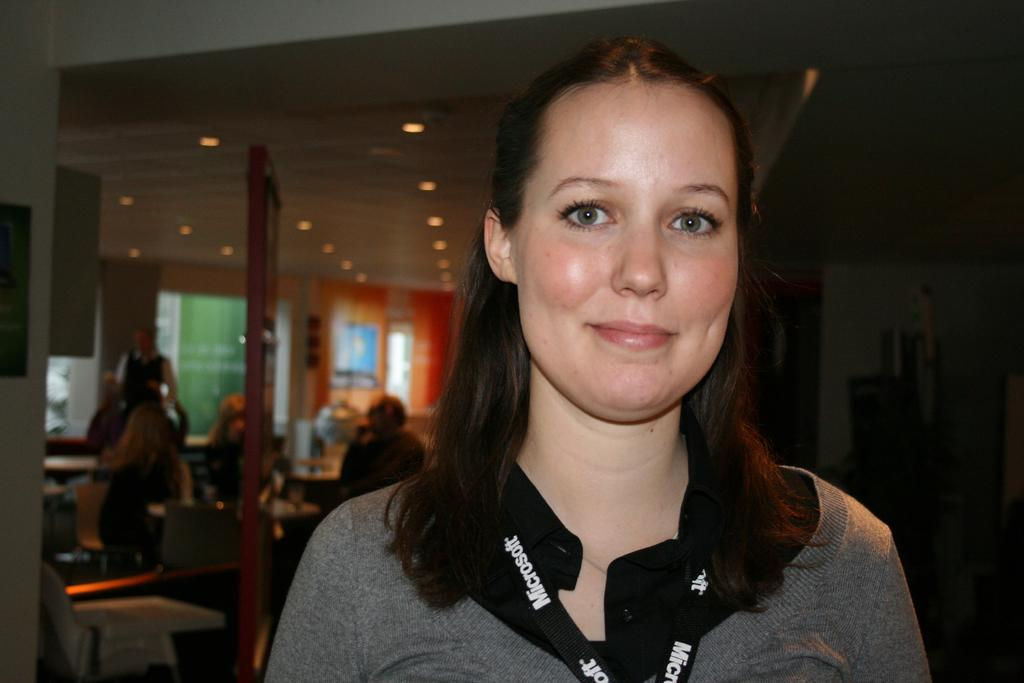<image>
Share a concise interpretation of the image provided. The girl shown is wearing a lanyard advertising microsoft. 